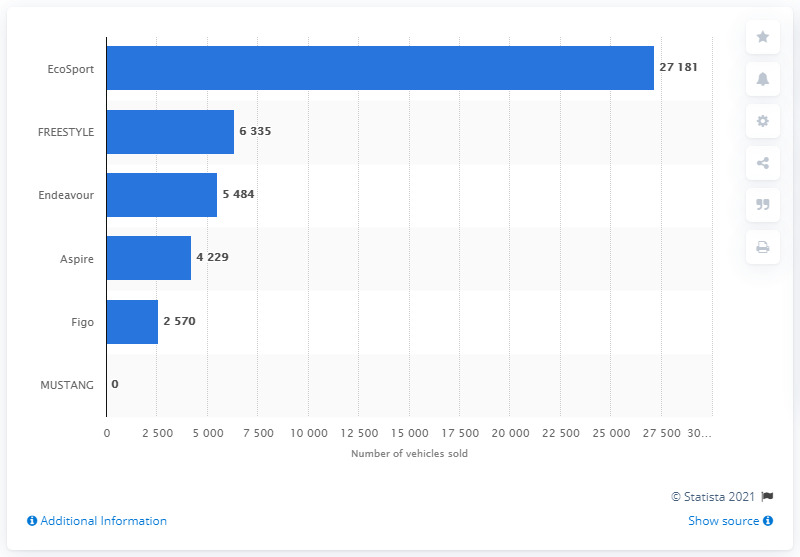Highlight a few significant elements in this photo. In 2020, a total of 27,181 units of the Ford EcoSport were sold in India. 